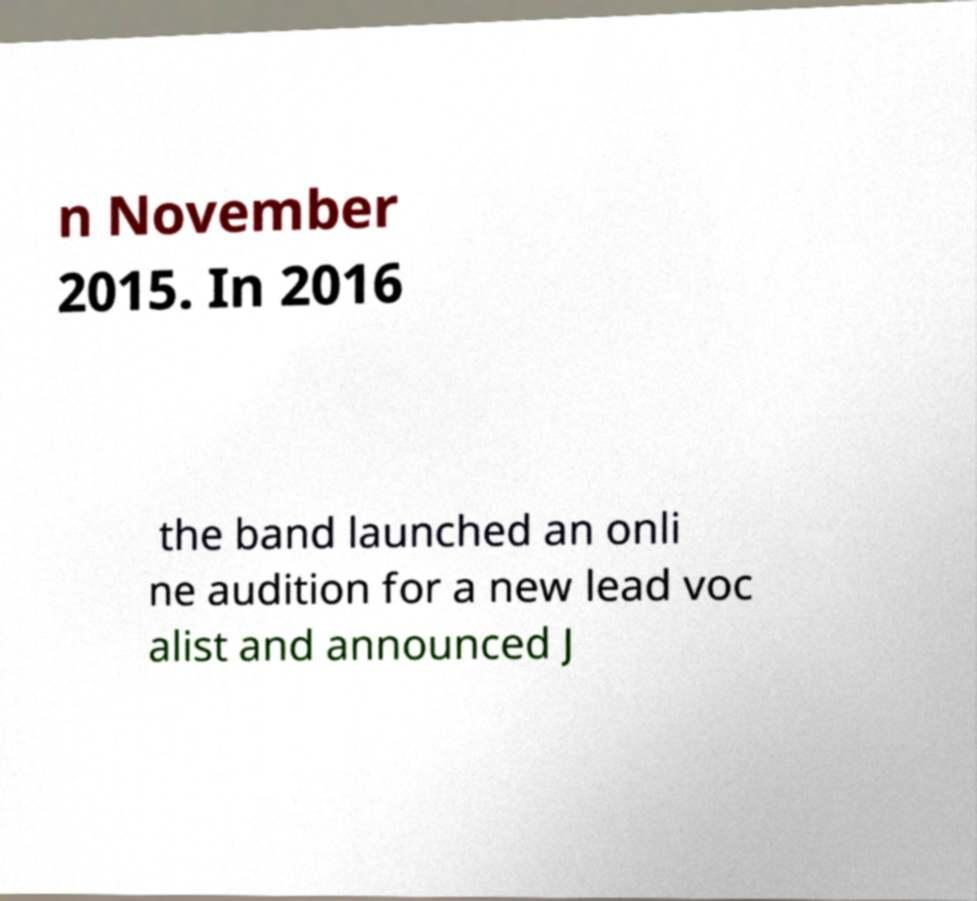Please read and relay the text visible in this image. What does it say? n November 2015. In 2016 the band launched an onli ne audition for a new lead voc alist and announced J 